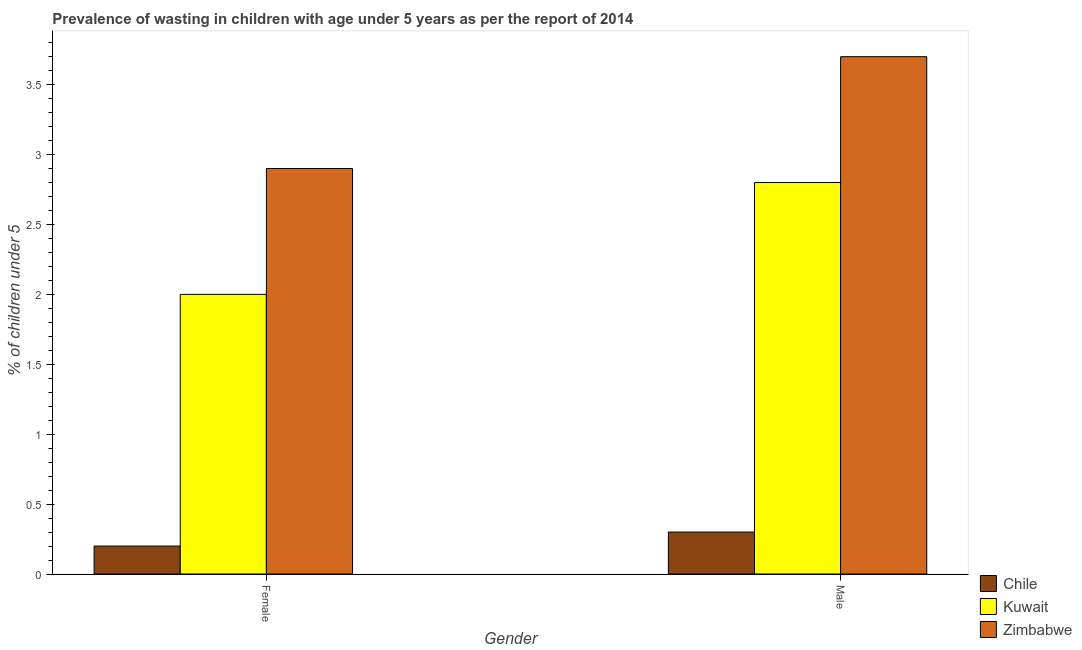How many different coloured bars are there?
Provide a succinct answer. 3. How many groups of bars are there?
Provide a short and direct response. 2. Are the number of bars per tick equal to the number of legend labels?
Keep it short and to the point. Yes. Are the number of bars on each tick of the X-axis equal?
Offer a very short reply. Yes. How many bars are there on the 2nd tick from the right?
Your answer should be compact. 3. What is the label of the 2nd group of bars from the left?
Offer a terse response. Male. What is the percentage of undernourished male children in Chile?
Ensure brevity in your answer.  0.3. Across all countries, what is the maximum percentage of undernourished male children?
Provide a succinct answer. 3.7. Across all countries, what is the minimum percentage of undernourished female children?
Provide a short and direct response. 0.2. In which country was the percentage of undernourished female children maximum?
Ensure brevity in your answer.  Zimbabwe. What is the total percentage of undernourished female children in the graph?
Ensure brevity in your answer.  5.1. What is the difference between the percentage of undernourished female children in Chile and that in Kuwait?
Your answer should be compact. -1.8. What is the difference between the percentage of undernourished male children in Zimbabwe and the percentage of undernourished female children in Chile?
Your answer should be very brief. 3.5. What is the average percentage of undernourished male children per country?
Offer a terse response. 2.27. What is the difference between the percentage of undernourished male children and percentage of undernourished female children in Chile?
Your answer should be very brief. 0.1. In how many countries, is the percentage of undernourished male children greater than 1 %?
Give a very brief answer. 2. What is the ratio of the percentage of undernourished male children in Zimbabwe to that in Kuwait?
Provide a succinct answer. 1.32. Is the percentage of undernourished male children in Kuwait less than that in Zimbabwe?
Offer a terse response. Yes. What does the 3rd bar from the left in Female represents?
Provide a succinct answer. Zimbabwe. What does the 2nd bar from the right in Male represents?
Make the answer very short. Kuwait. How many bars are there?
Your response must be concise. 6. Are all the bars in the graph horizontal?
Make the answer very short. No. What is the difference between two consecutive major ticks on the Y-axis?
Provide a succinct answer. 0.5. What is the title of the graph?
Your answer should be very brief. Prevalence of wasting in children with age under 5 years as per the report of 2014. Does "Kosovo" appear as one of the legend labels in the graph?
Make the answer very short. No. What is the label or title of the X-axis?
Ensure brevity in your answer.  Gender. What is the label or title of the Y-axis?
Keep it short and to the point.  % of children under 5. What is the  % of children under 5 in Chile in Female?
Keep it short and to the point. 0.2. What is the  % of children under 5 of Kuwait in Female?
Keep it short and to the point. 2. What is the  % of children under 5 in Zimbabwe in Female?
Ensure brevity in your answer.  2.9. What is the  % of children under 5 in Chile in Male?
Offer a terse response. 0.3. What is the  % of children under 5 in Kuwait in Male?
Keep it short and to the point. 2.8. What is the  % of children under 5 in Zimbabwe in Male?
Give a very brief answer. 3.7. Across all Gender, what is the maximum  % of children under 5 of Chile?
Keep it short and to the point. 0.3. Across all Gender, what is the maximum  % of children under 5 of Kuwait?
Give a very brief answer. 2.8. Across all Gender, what is the maximum  % of children under 5 in Zimbabwe?
Your response must be concise. 3.7. Across all Gender, what is the minimum  % of children under 5 in Chile?
Provide a short and direct response. 0.2. Across all Gender, what is the minimum  % of children under 5 in Zimbabwe?
Your answer should be compact. 2.9. What is the total  % of children under 5 in Zimbabwe in the graph?
Offer a terse response. 6.6. What is the difference between the  % of children under 5 of Kuwait in Female and that in Male?
Make the answer very short. -0.8. What is the difference between the  % of children under 5 of Chile in Female and the  % of children under 5 of Kuwait in Male?
Offer a terse response. -2.6. What is the difference between the  % of children under 5 in Kuwait and  % of children under 5 in Zimbabwe in Female?
Provide a short and direct response. -0.9. What is the difference between the  % of children under 5 of Chile and  % of children under 5 of Kuwait in Male?
Provide a short and direct response. -2.5. What is the difference between the  % of children under 5 of Chile and  % of children under 5 of Zimbabwe in Male?
Your answer should be very brief. -3.4. What is the difference between the  % of children under 5 in Kuwait and  % of children under 5 in Zimbabwe in Male?
Offer a terse response. -0.9. What is the ratio of the  % of children under 5 of Chile in Female to that in Male?
Provide a succinct answer. 0.67. What is the ratio of the  % of children under 5 of Zimbabwe in Female to that in Male?
Provide a succinct answer. 0.78. What is the difference between the highest and the second highest  % of children under 5 of Chile?
Your response must be concise. 0.1. What is the difference between the highest and the second highest  % of children under 5 in Kuwait?
Make the answer very short. 0.8. 